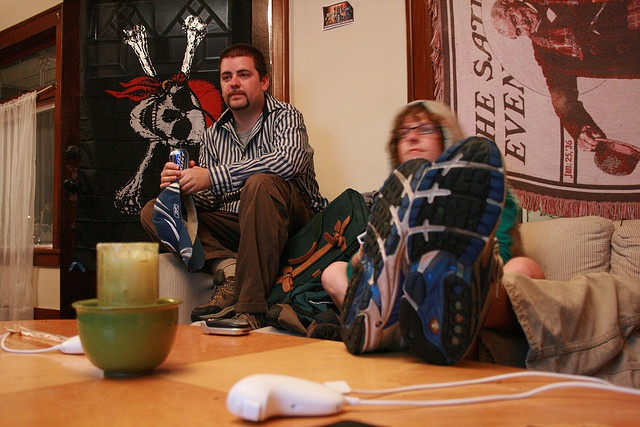Describe the objects in this image and their specific colors. I can see people in tan, black, maroon, brown, and gray tones, couch in tan, gray, black, and brown tones, people in tan, brown, maroon, and black tones, bowl in tan, olive, maroon, and black tones, and backpack in tan, black, maroon, and brown tones in this image. 